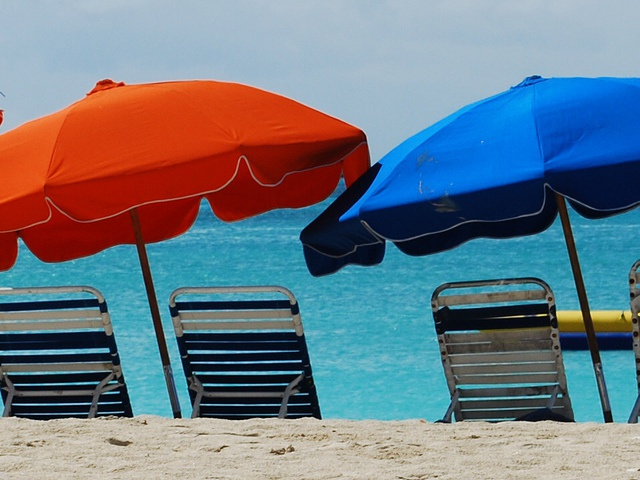Describe the objects in this image and their specific colors. I can see umbrella in darkgray, maroon, and red tones, umbrella in lightblue, black, blue, and gray tones, chair in lightblue, black, gray, teal, and darkgreen tones, chair in lightblue, black, gray, and teal tones, and chair in lightblue, black, gray, and teal tones in this image. 